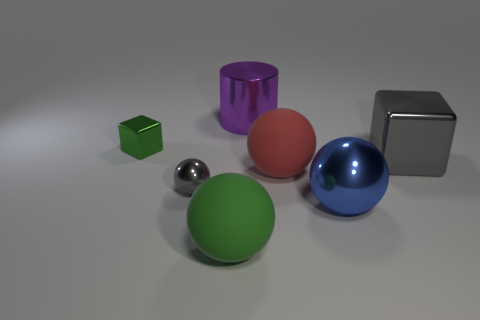Subtract all big balls. How many balls are left? 1 Subtract all cubes. How many objects are left? 5 Add 1 large red rubber objects. How many objects exist? 8 Subtract all red spheres. How many spheres are left? 3 Subtract all purple cubes. Subtract all gray balls. How many cubes are left? 2 Subtract all gray spheres. How many gray blocks are left? 1 Subtract all cyan matte cylinders. Subtract all green spheres. How many objects are left? 6 Add 5 tiny cubes. How many tiny cubes are left? 6 Add 7 metal cylinders. How many metal cylinders exist? 8 Subtract 0 yellow cubes. How many objects are left? 7 